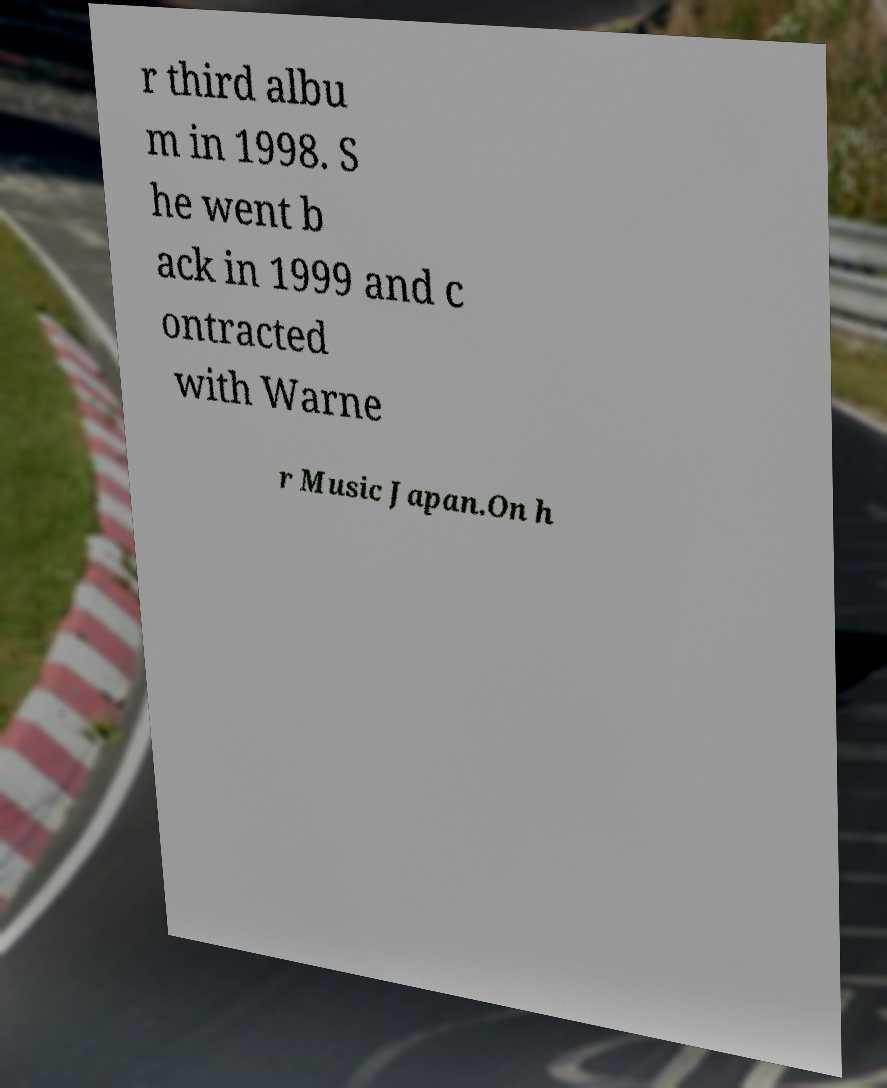I need the written content from this picture converted into text. Can you do that? r third albu m in 1998. S he went b ack in 1999 and c ontracted with Warne r Music Japan.On h 